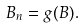Convert formula to latex. <formula><loc_0><loc_0><loc_500><loc_500>B _ { n } = g ( B ) .</formula> 